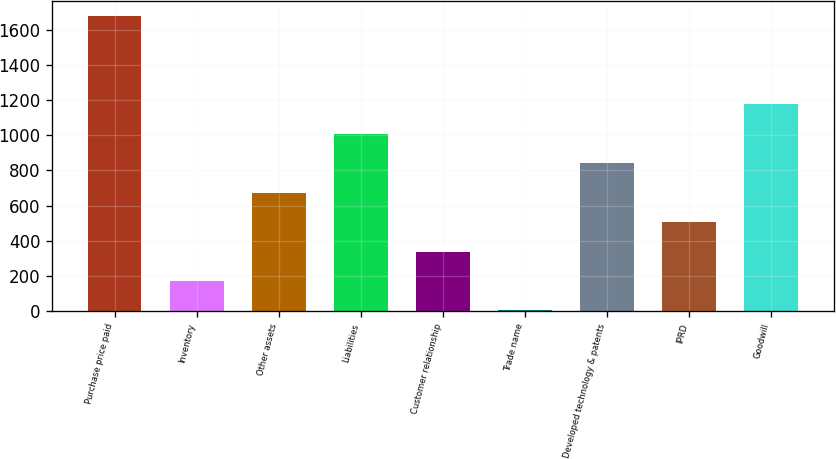<chart> <loc_0><loc_0><loc_500><loc_500><bar_chart><fcel>Purchase price paid<fcel>Inventory<fcel>Other assets<fcel>Liabilities<fcel>Customer relationship<fcel>Trade name<fcel>Developed technology & patents<fcel>IPRD<fcel>Goodwill<nl><fcel>1677<fcel>171.3<fcel>673.2<fcel>1007.8<fcel>338.6<fcel>4<fcel>840.5<fcel>505.9<fcel>1175.1<nl></chart> 